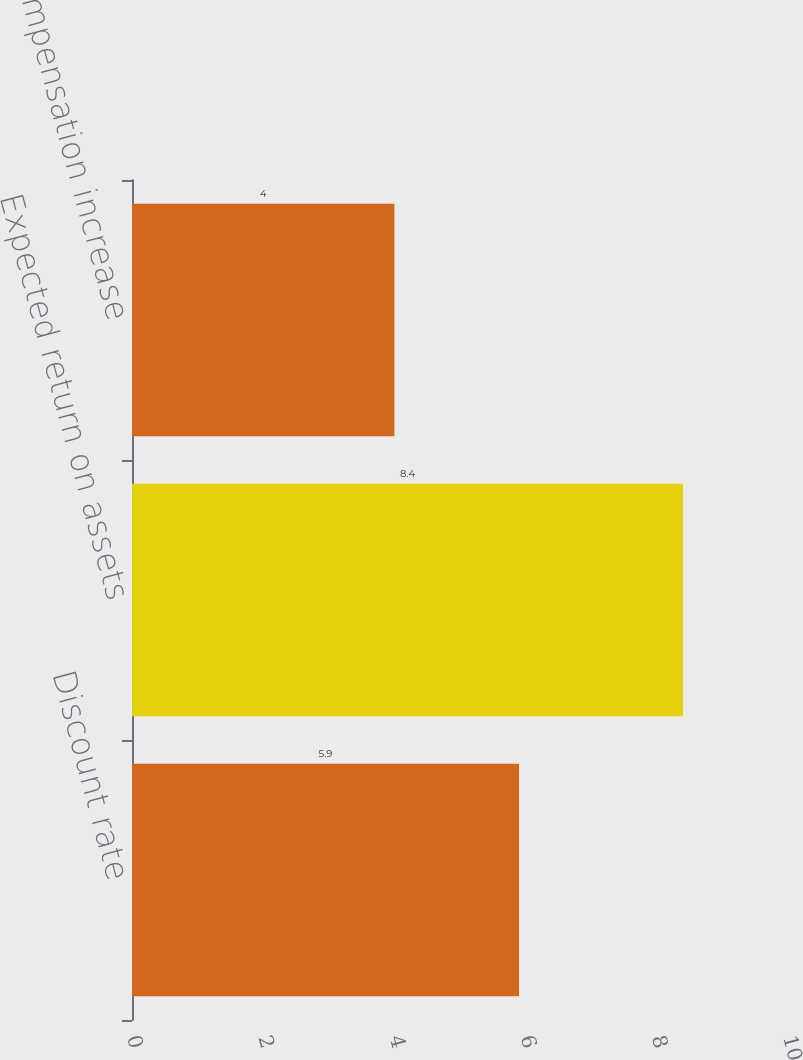Convert chart. <chart><loc_0><loc_0><loc_500><loc_500><bar_chart><fcel>Discount rate<fcel>Expected return on assets<fcel>Rate of compensation increase<nl><fcel>5.9<fcel>8.4<fcel>4<nl></chart> 